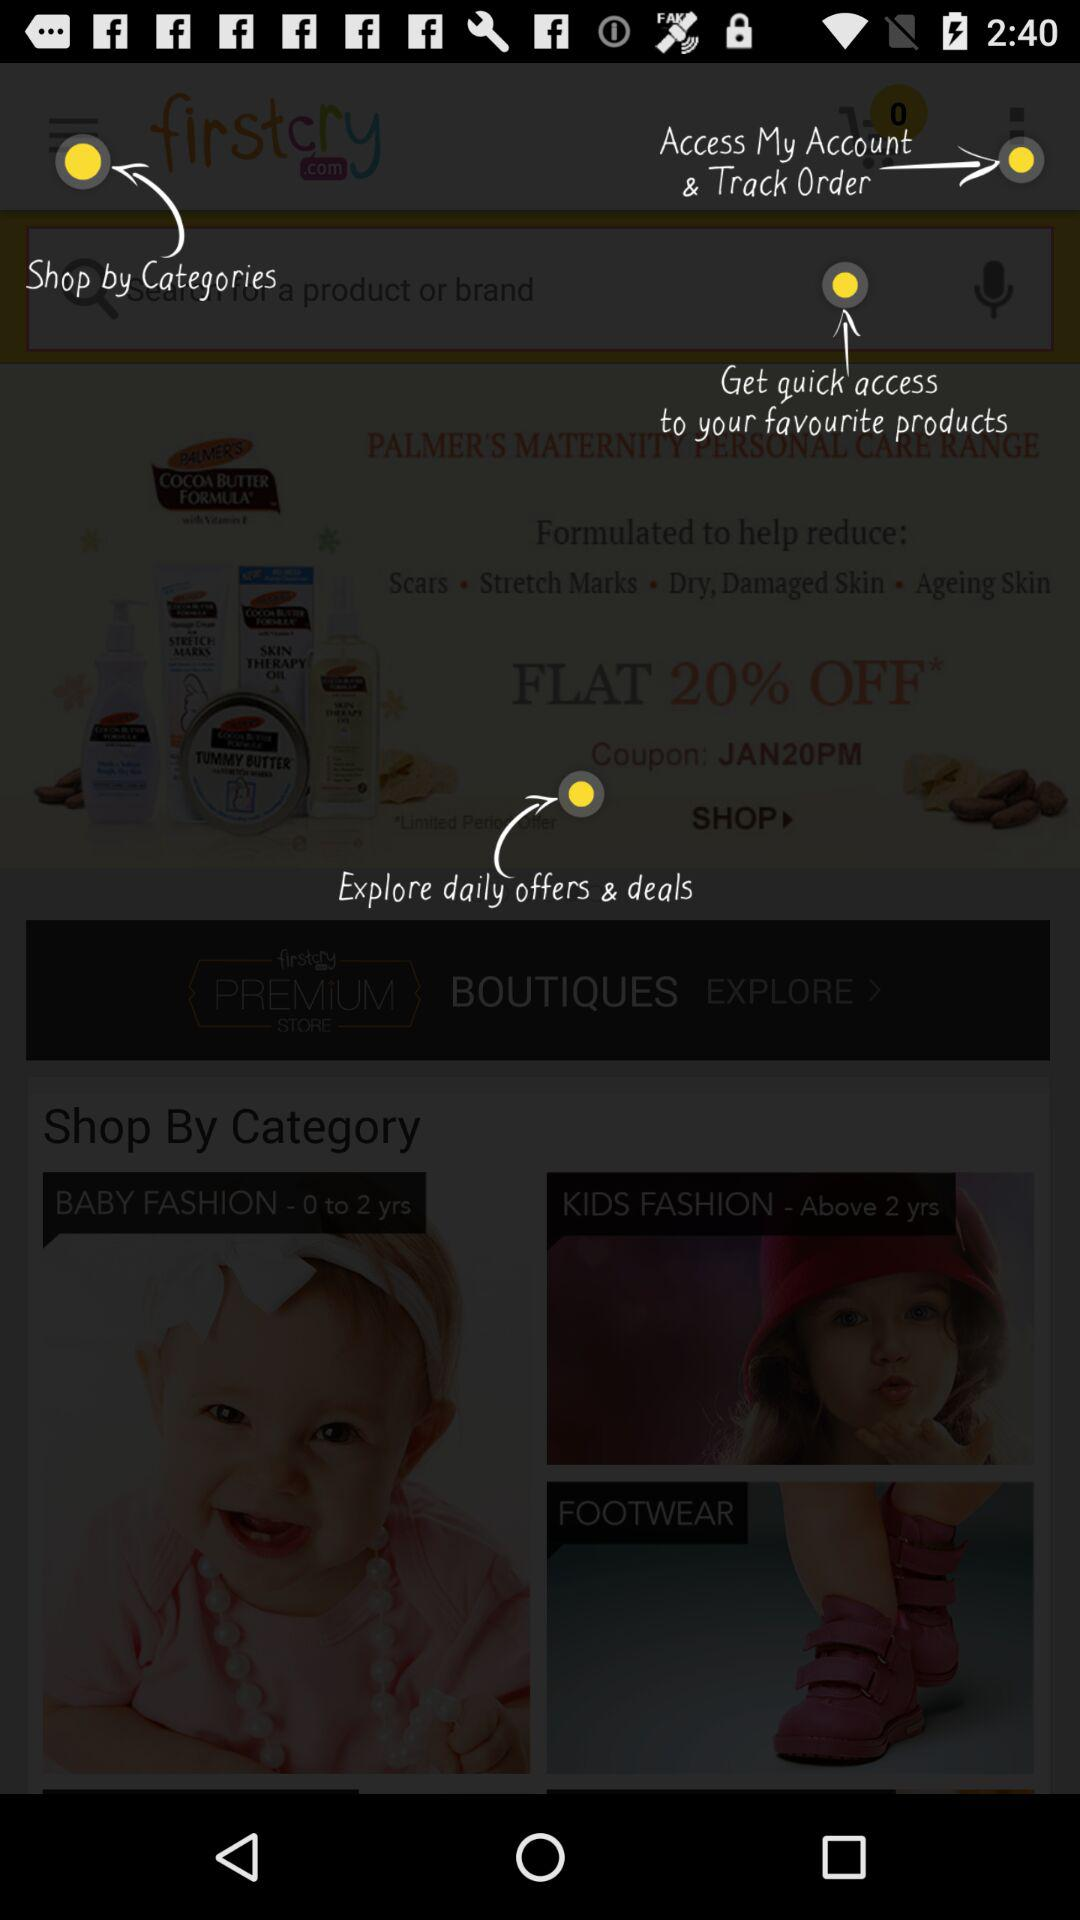How much of a percentage is off on maternity personal care? There is 20% off on maternity personal care. 